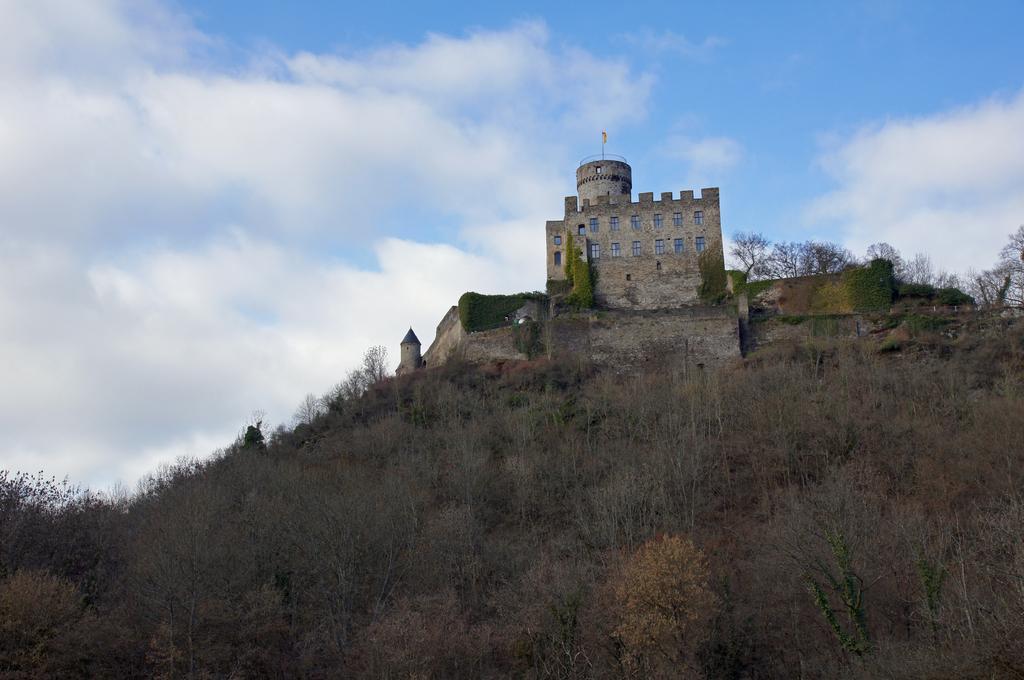Could you give a brief overview of what you see in this image? In the center of the image we can see a castle and there are trees. In the background there is sky. 